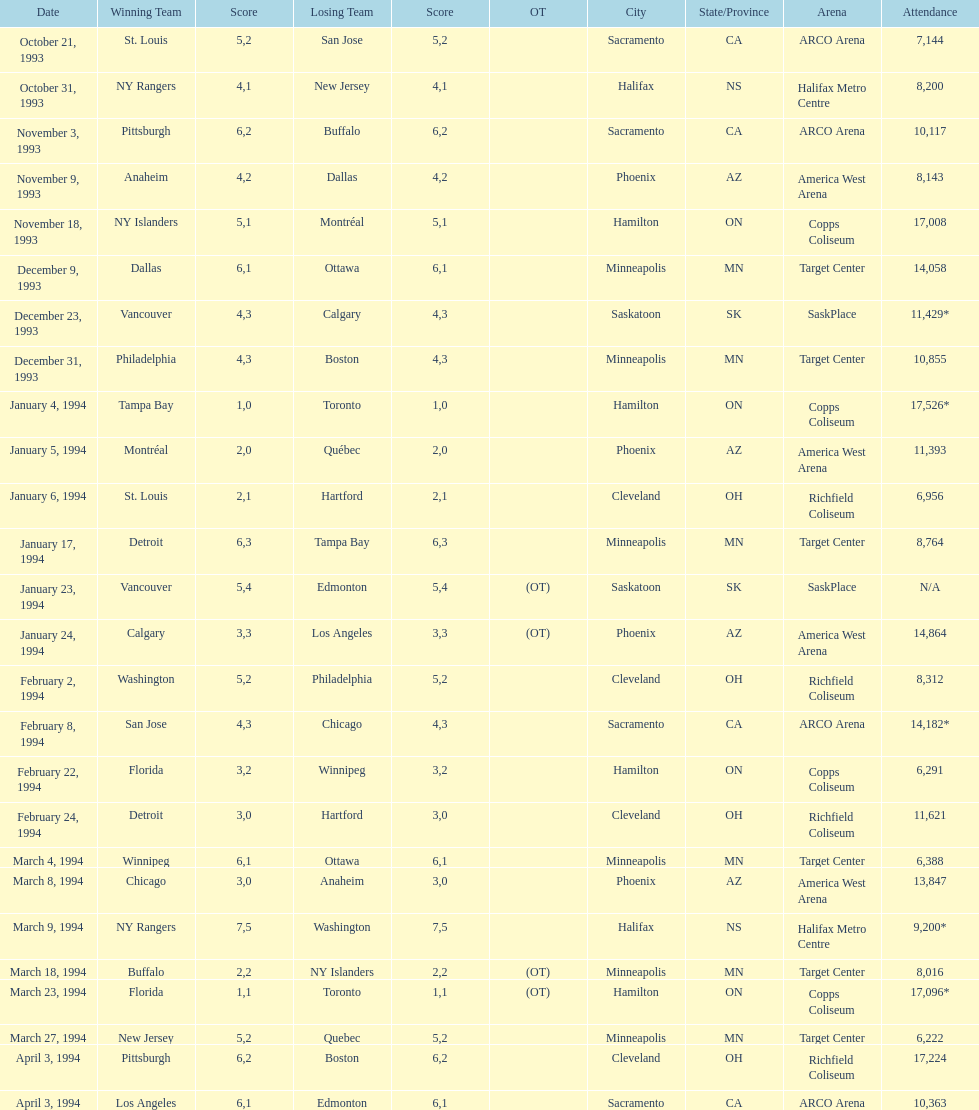When was the game with the most spectators held? January 4, 1994. 